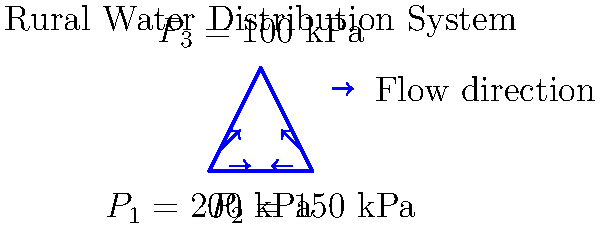In a rural water distribution system, three interconnected pipes form a triangular network as shown in the diagram. The pressures at the three junctions are $P_1 = 200$ kPa, $P_2 = 150$ kPa, and $P_3 = 100$ kPa. If the pipes have equal diameters and lengths, determine the direction of water flow in each pipe and calculate the pressure gradient (pressure drop per unit length) in the pipe connecting $P_1$ and $P_2$. To solve this problem, we'll follow these steps:

1. Determine the flow direction:
   - Water flows from higher pressure to lower pressure.
   - $P_1 (200 \text{ kPa}) > P_2 (150 \text{ kPa}) > P_3 (100 \text{ kPa})$
   - Flow direction: $P_1 \rightarrow P_2$, $P_1 \rightarrow P_3$, and $P_2 \rightarrow P_3$

2. Calculate the pressure gradient in the pipe connecting $P_1$ and $P_2$:
   - Pressure difference: $\Delta P = P_1 - P_2 = 200 \text{ kPa} - 150 \text{ kPa} = 50 \text{ kPa}$
   - The pipes have equal lengths, so let's assume each pipe has a length $L$.
   - Pressure gradient = Pressure drop / Length = $\frac{\Delta P}{L} = \frac{50 \text{ kPa}}{L}$

3. Express the final answer:
   The pressure gradient in the pipe connecting $P_1$ and $P_2$ is $\frac{50 \text{ kPa}}{L}$, where $L$ is the length of the pipe.
Answer: $\frac{50 \text{ kPa}}{L}$ 